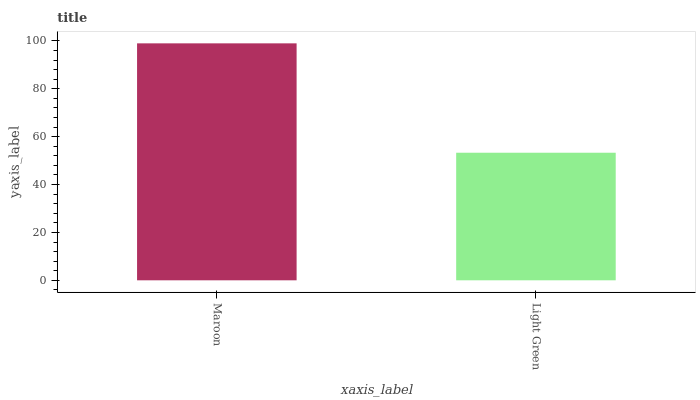Is Light Green the maximum?
Answer yes or no. No. Is Maroon greater than Light Green?
Answer yes or no. Yes. Is Light Green less than Maroon?
Answer yes or no. Yes. Is Light Green greater than Maroon?
Answer yes or no. No. Is Maroon less than Light Green?
Answer yes or no. No. Is Maroon the high median?
Answer yes or no. Yes. Is Light Green the low median?
Answer yes or no. Yes. Is Light Green the high median?
Answer yes or no. No. Is Maroon the low median?
Answer yes or no. No. 